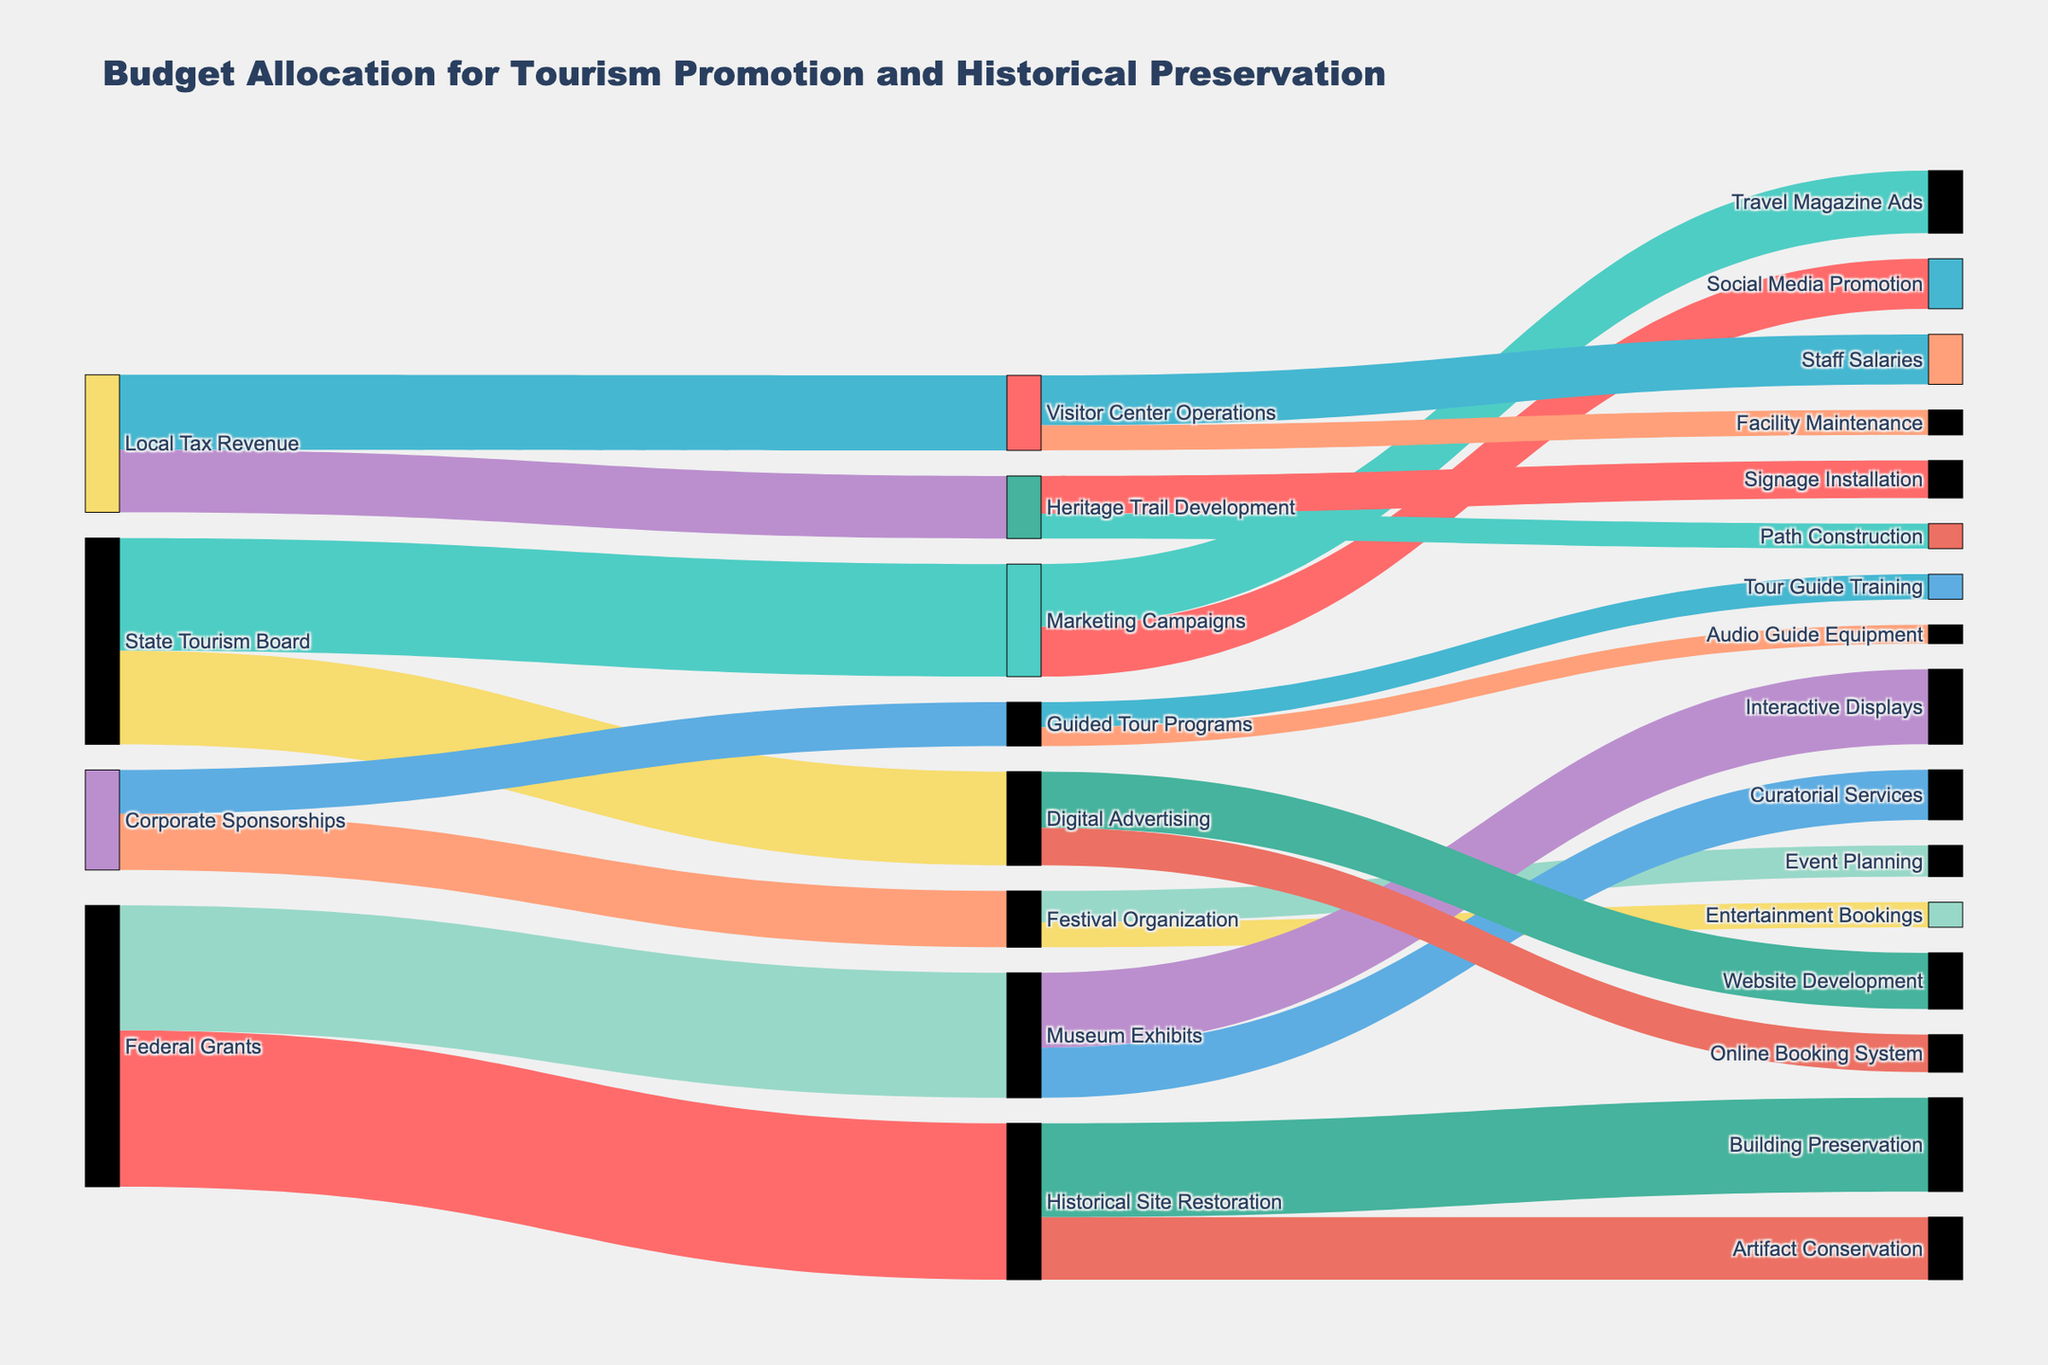What is the title of the figure? The title is displayed at the top of the figure and reads "Budget Allocation for Tourism Promotion and Historical Preservation".
Answer: Budget Allocation for Tourism Promotion and Historical Preservation Which funding source has the highest allocation? By observing the source nodes and their connecting links, the source node "Federal Grants" has the highest value connections with a total sum of 450,000 (250,000 for Historical Site Restoration and 200,000 for Museum Exhibits).
Answer: Federal Grants What is the total budget allocated by Corporate Sponsorships? Sum the values of the links starting from "Corporate Sponsorships": 90,000 for Festival Organization and 70,000 for Guided Tour Programs, resulting in a total of 160,000.
Answer: 160,000 How much budget is allocated to Visitor Center Operations? The links targetting "Visitor Center Operations" sum up to 120,000 from Local Tax Revenue.
Answer: 120,000 Compare the budget allocation between Marketing Campaigns and Museum Exhibits. Marketing Campaigns receive a total of 180,000 from State Tourism Board, while Museum Exhibits receive 200,000 from Federal Grants. The Museum Exhibits receive more funding.
Answer: Museum Exhibits receive more funding How much is allocated to Digital Advertising from the State Tourism Board? The link from "State Tourism Board" to "Digital Advertising" indicates a value of 150,000.
Answer: 150,000 What are the two subcategories of Heritage Trail Development and their respective allocations? The links from "Heritage Trail Development" show 60,000 for Signage Installation and 40,000 for Path Construction.
Answer: Signage Installation: 60,000, Path Construction: 40,000 What is the combined budget for all expenditures under Historical Site Restoration? The links from "Historical Site Restoration" show 150,000 for Building Preservation and 100,000 for Artifact Conservation, totaling 250,000.
Answer: 250,000 Which funding sources contribute to the Marketing Campaigns, and how much do they each contribute? The links to "Marketing Campaigns" show contributions from the State Tourism Board: 180,000.
Answer: State Tourism Board: 180,000 